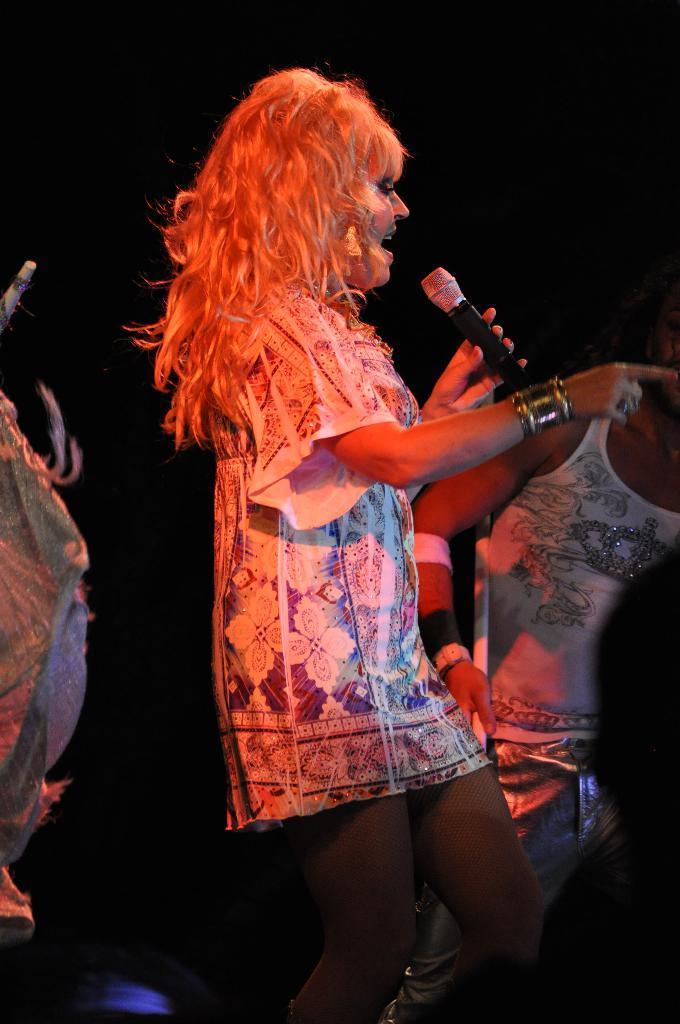Describe this image in one or two sentences. a person is singing holding a microphone in her hand. behind her there is another person 